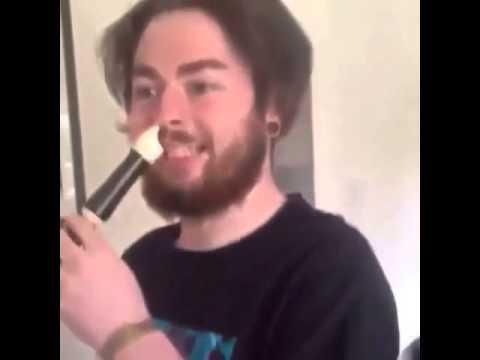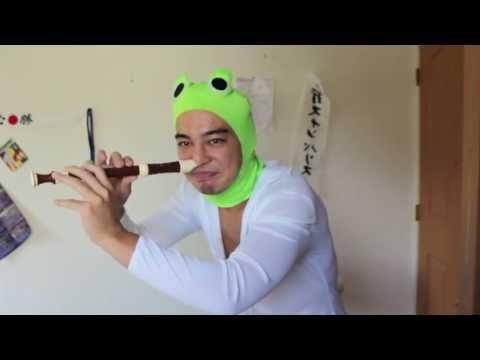The first image is the image on the left, the second image is the image on the right. Analyze the images presented: Is the assertion "The left and right image contains the same number of men playing the flute and at least one man is wearing a green hat." valid? Answer yes or no. Yes. The first image is the image on the left, the second image is the image on the right. Evaluate the accuracy of this statement regarding the images: "Each image shows a male holding a flute to one nostril, and the right image features a man in a green frog-eye head covering and white shirt.". Is it true? Answer yes or no. Yes. 